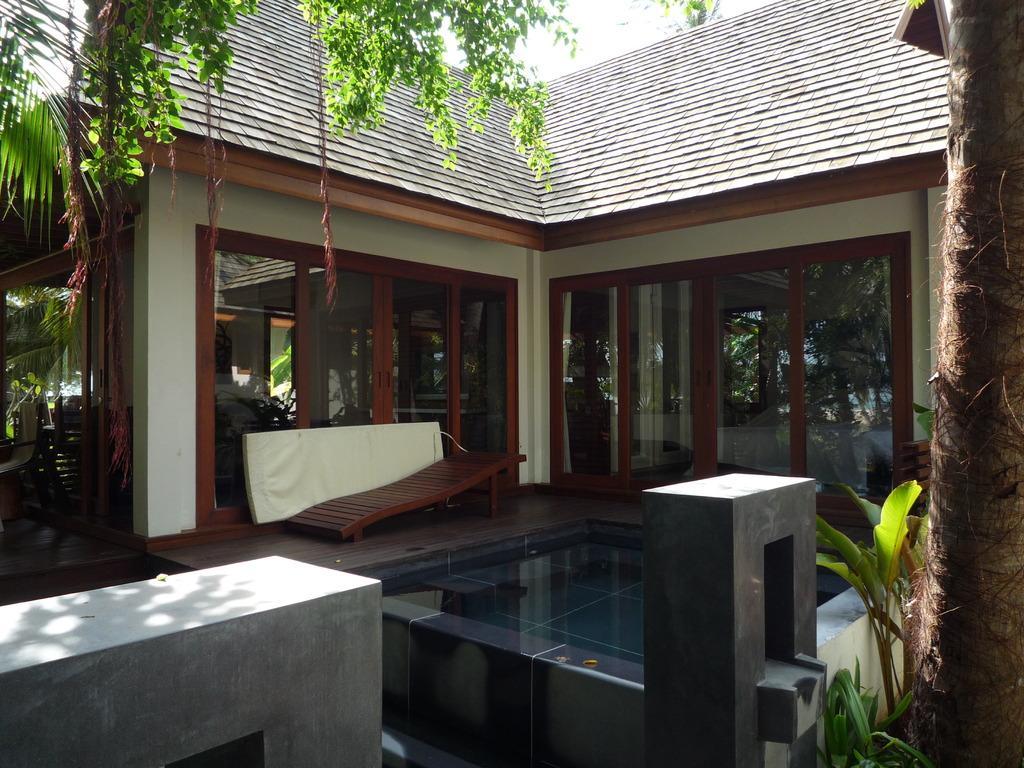Describe this image in one or two sentences. In this image I can see the house which is in brown color. I can see the glasses to the side. To the side there are many trees and plants. In the back I can see the sky. 